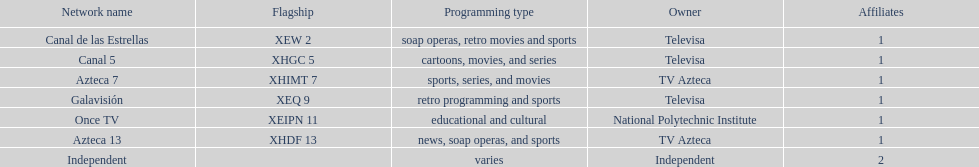How many networks refrain from airing sports content? 2. 